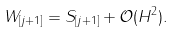<formula> <loc_0><loc_0><loc_500><loc_500>W _ { [ j + 1 ] } & = S _ { [ j + 1 ] } + \mathcal { O } ( \| H \| ^ { 2 } ) .</formula> 